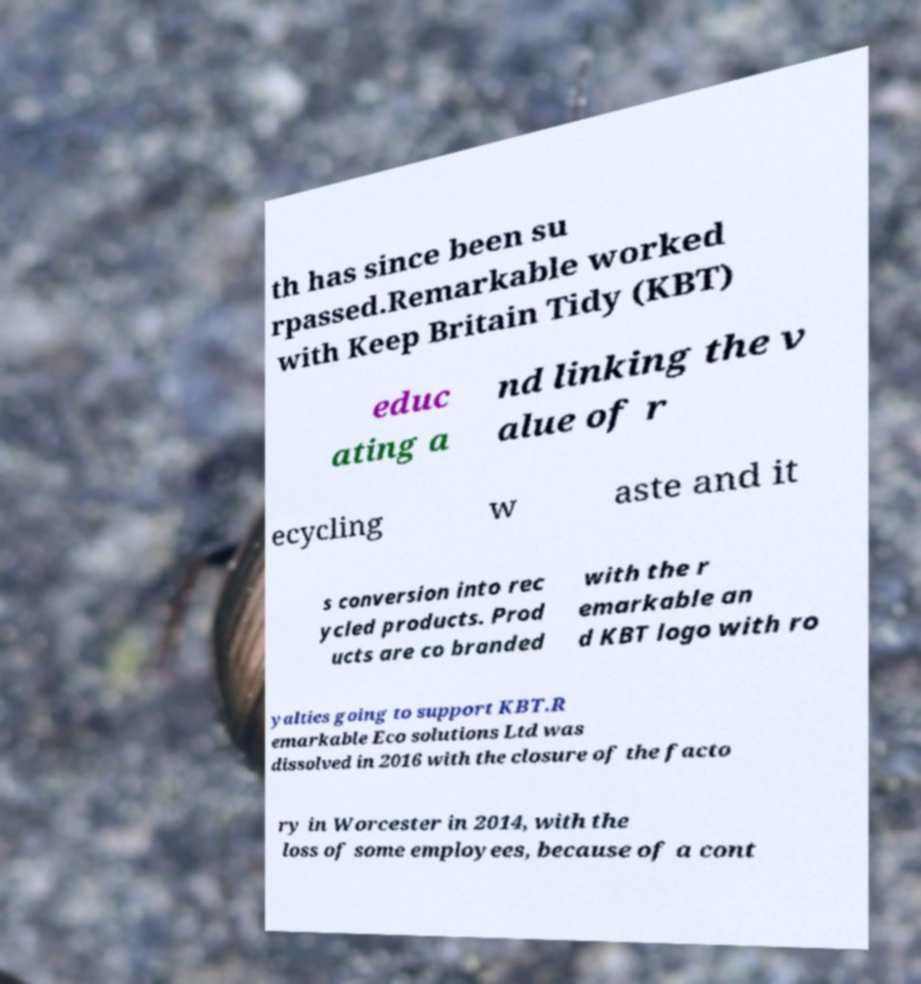There's text embedded in this image that I need extracted. Can you transcribe it verbatim? th has since been su rpassed.Remarkable worked with Keep Britain Tidy (KBT) educ ating a nd linking the v alue of r ecycling w aste and it s conversion into rec ycled products. Prod ucts are co branded with the r emarkable an d KBT logo with ro yalties going to support KBT.R emarkable Eco solutions Ltd was dissolved in 2016 with the closure of the facto ry in Worcester in 2014, with the loss of some employees, because of a cont 